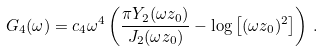Convert formula to latex. <formula><loc_0><loc_0><loc_500><loc_500>G _ { 4 } ( \omega ) = c _ { 4 } \omega ^ { 4 } \left ( \frac { \pi Y _ { 2 } ( \omega z _ { 0 } ) } { J _ { 2 } ( \omega z _ { 0 } ) } - \log \left [ ( \omega z _ { 0 } ) ^ { 2 } \right ] \right ) \, .</formula> 